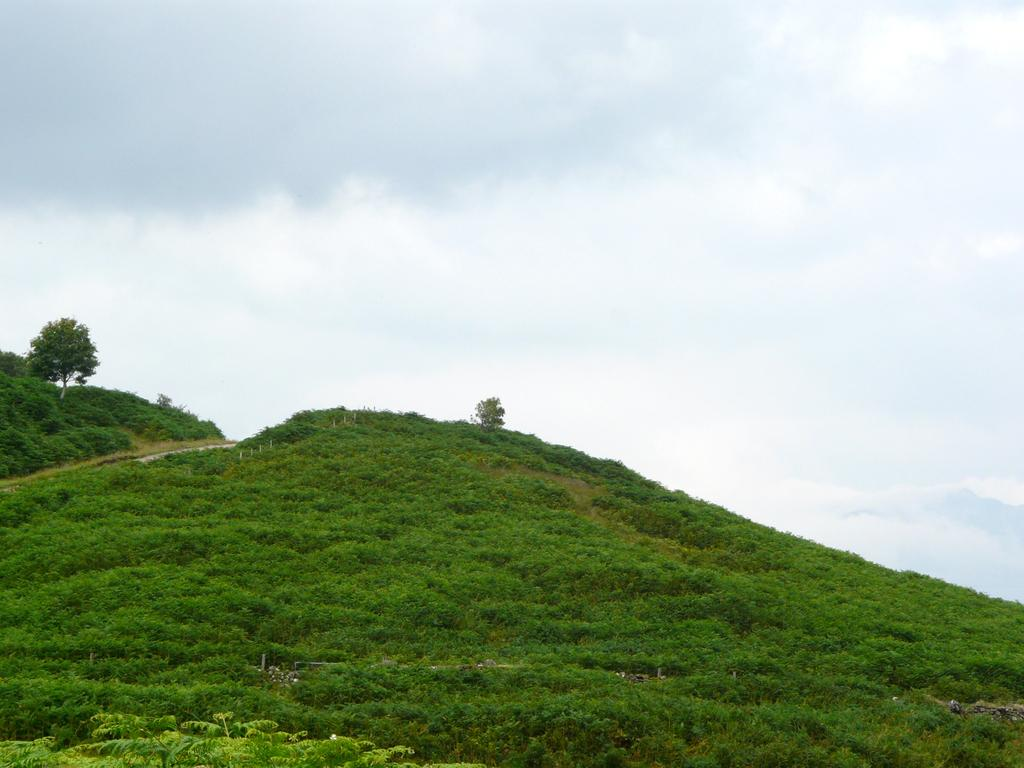What type of landscape feature is present in the image? There is a hill in the image. What can be seen growing on the hill and around it? There are many trees and plants in the image. How would you describe the sky in the image? The sky is cloudy in the image. What type of clam can be seen crawling on the hill in the image? There are no clams present in the image; it features a hill with trees and plants. How does the rice contribute to the landscape in the image? There is no rice present in the image; it features a hill with trees and plants. 